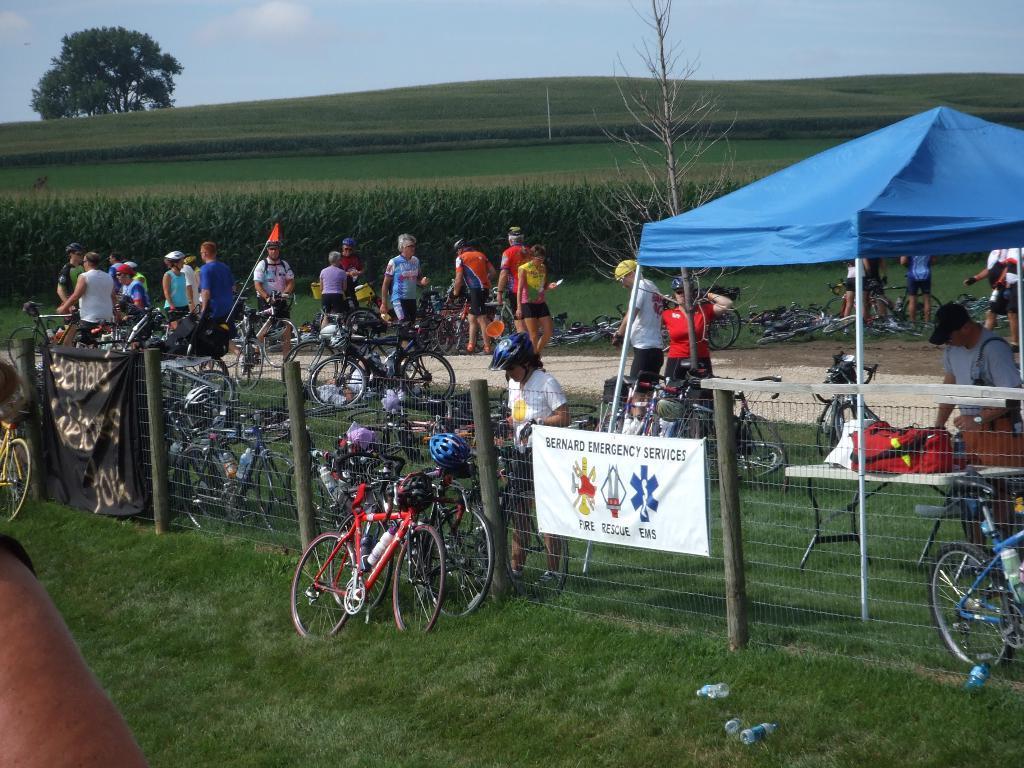Describe this image in one or two sentences. In this image there are bicycles on the grassland. Few banners are attached to the fence. Right side a person wearing a cap is standing under the tent. Before him there is a table having few bags. Few people are on the path. Few people are standing on the grassland having plants. Left bottom a person's hand is visible. Left top there are trees on the grassland. Top of the image there is sky. 